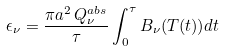Convert formula to latex. <formula><loc_0><loc_0><loc_500><loc_500>\epsilon _ { \nu } = \frac { \pi a ^ { 2 } \, Q ^ { a b s } _ { \nu } } { \tau } \int _ { 0 } ^ { \tau } B _ { \nu } ( T ( t ) ) d t</formula> 